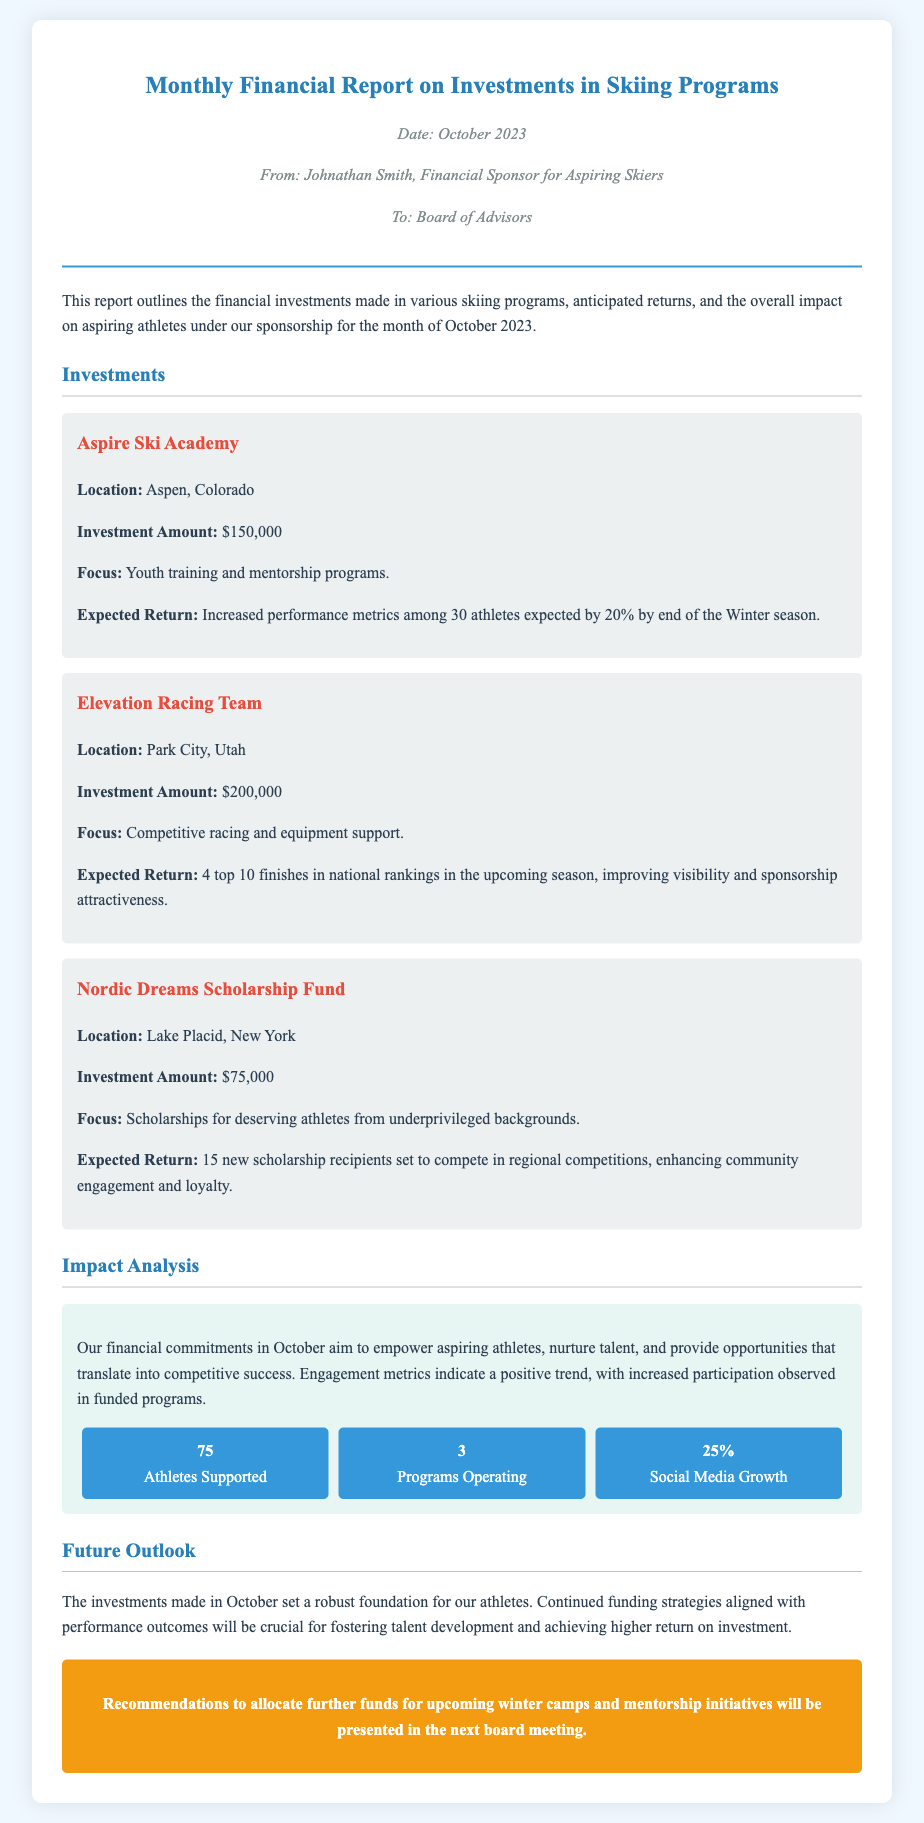What is the date of the report? The date mentioned in the memo is specifically stated in the meta section as October 2023.
Answer: October 2023 Who is the financial sponsor? The financial sponsor is identified in the memo header as Johnathan Smith.
Answer: Johnathan Smith What is the investment amount for Aspire Ski Academy? The investment amount for Aspire Ski Academy is specified in the investment section of the report.
Answer: $150,000 How many athletes are expected to increase performance metrics by 20%? The report indicates that 30 athletes are involved in the performance increase expectation.
Answer: 30 athletes What focus area does the Nordic Dreams Scholarship Fund concentrate on? The focus area can be found in the investment details of the Nordic Dreams Scholarship Fund.
Answer: Scholarships for deserving athletes from underprivileged backgrounds What is the expected outcome for the Elevation Racing Team? The expected outcome is defined in the investment section outlining the anticipated top 10 finishes.
Answer: 4 top 10 finishes What is stated as the social media growth percentage? The social media growth percentage is presented in the impact analysis under key metrics.
Answer: 25% How many programs are currently operating according to the impact analysis? The document specifies that there are 3 programs operating as part of the engagement metrics.
Answer: 3 programs What is mentioned as a future recommendation in the report? The call-to-action section highlights a recommendation for future funding strategies related to winter camps.
Answer: Allocate further funds for upcoming winter camps and mentorship initiatives 